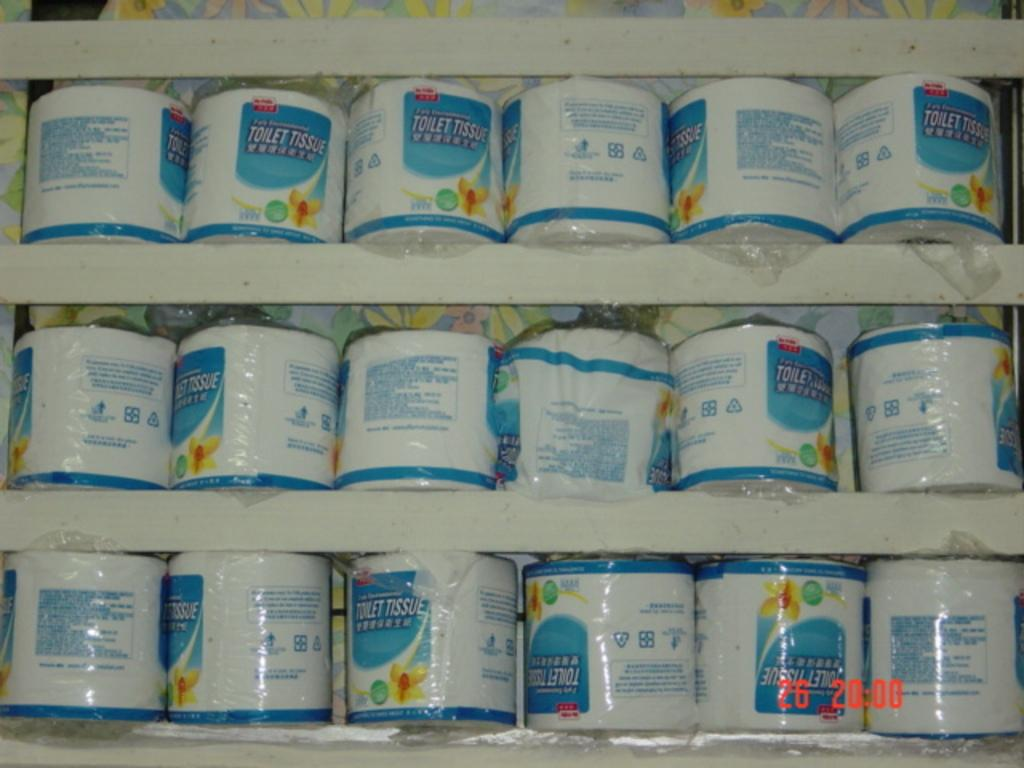<image>
Write a terse but informative summary of the picture. A row of toilet paper rolls individually packaged and labeled Toilet Tissue. 